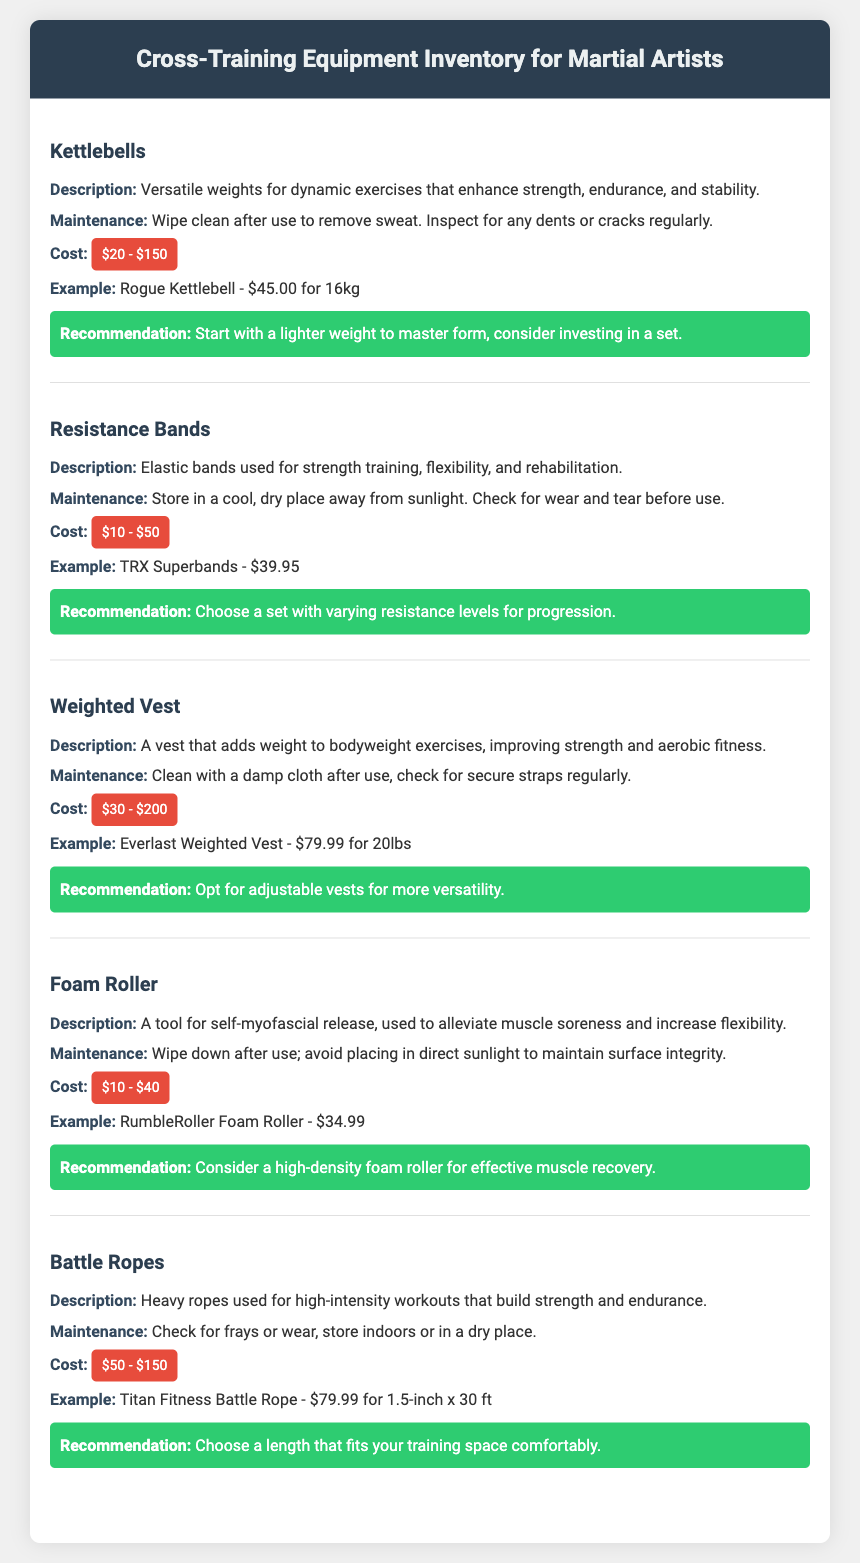What is the description of Kettlebells? The description provides a brief insight into the utility of kettlebells, specifically highlighting their versatile nature for dynamic exercises that enhance strength, endurance, and stability.
Answer: Versatile weights for dynamic exercises that enhance strength, endurance, and stability What is the cost range for Resistance Bands? The cost range is clearly specified, indicating the amount that one might expect to pay for resistance bands as listed in the document.
Answer: $10 - $50 What maintenance advice is given for the Weighted Vest? The document advises on care, specifically how to clean and inspect the equipment to ensure its functioning and longevity.
Answer: Clean with a damp cloth after use, check for secure straps regularly What is recommended for the Foam Roller? Recommendations are provided in the document, helping users make informed decisions about what type of foam roller to consider based on its effectiveness for muscle recovery.
Answer: Consider a high-density foam roller for effective muscle recovery What example of a Kettlebell is provided in the document? The document presents an example of a specific kettlebell along with its price, helping readers to find a reference product if they wish to purchase.
Answer: Rogue Kettlebell - $45.00 for 16kg Which equipment item is mentioned to use heavy ropes? The document specifically mentions the equipment that utilizes heavy ropes for workouts, which is essential information for understanding its purpose.
Answer: Battle Ropes What is the maintenance advice for Battle Ropes? The document states the necessary maintenance tips that should be followed to ensure the longevity and effectiveness of battle ropes.
Answer: Check for frays or wear, store indoors or in a dry place What is the cost range for a Weighted Vest? The cost range is specified, offering potential buyers a clear understanding of what to expect when looking for a weighted vest.
Answer: $30 - $200 